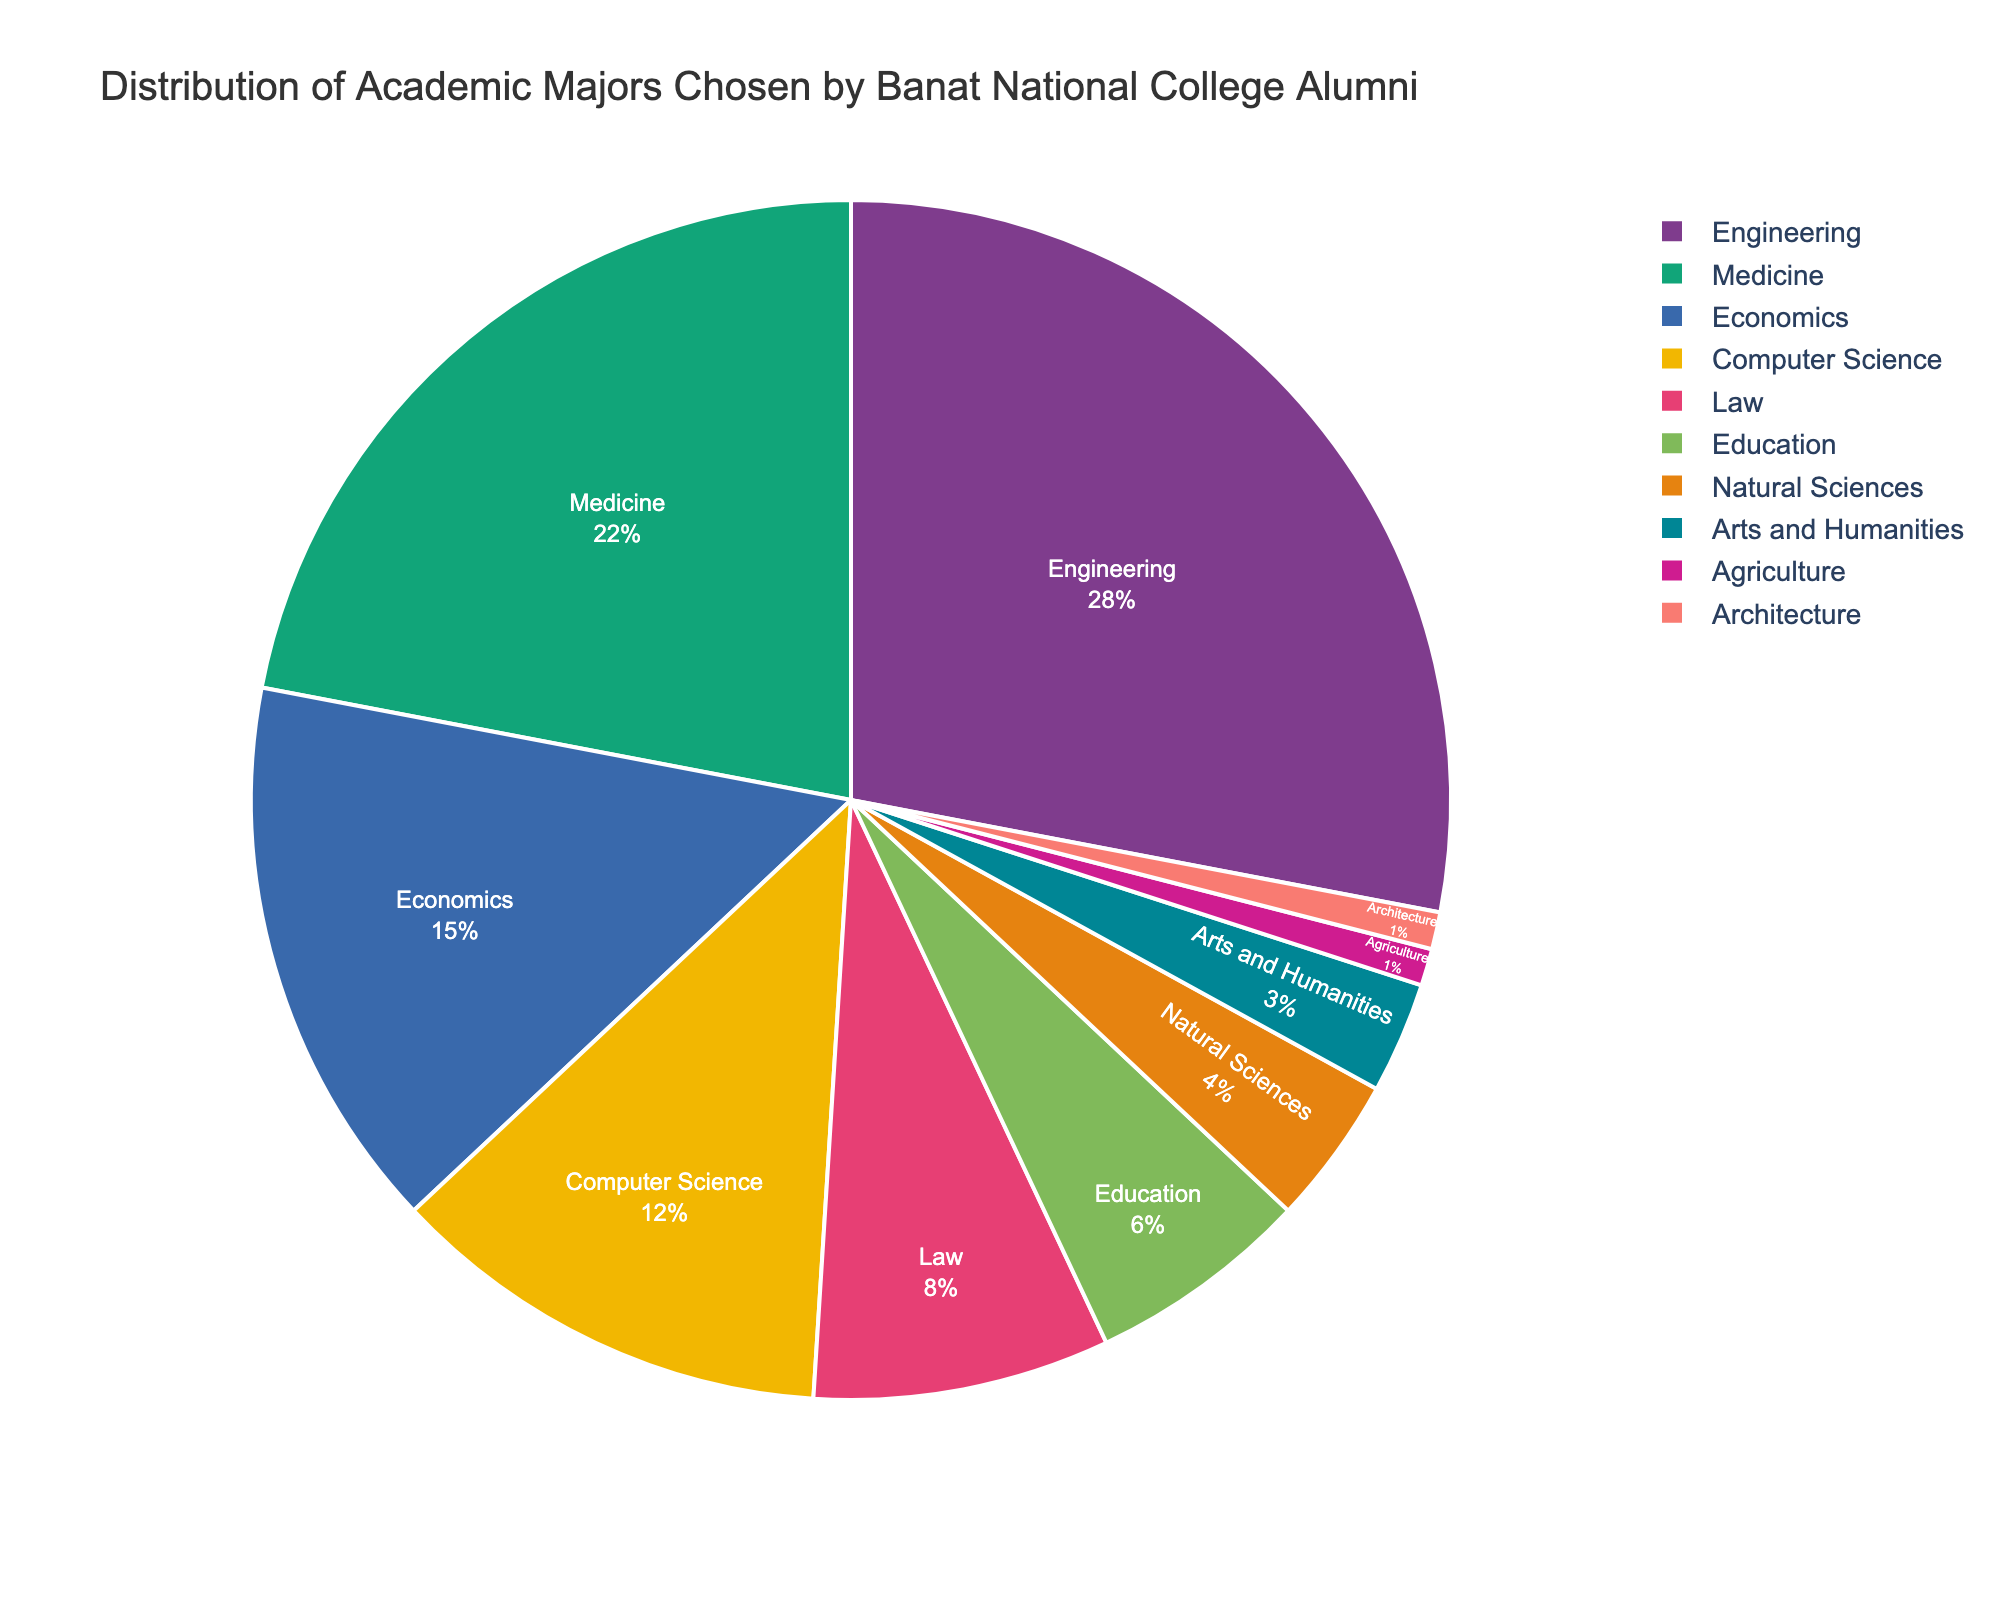Which major has the highest percentage of alumni? By visually inspecting the pie chart, we can see that Engineering appears to have the largest section. Confirm by noting it covers 28%.
Answer: Engineering What is the combined percentage of alumni in Medicine and Computer Science? From the pie chart, the Medicine slice is 22% and the Computer Science slice is 12%. Summing these two gives us 22 + 12 = 34%.
Answer: 34% How much more popular is Engineering compared to Law? Engineering has a percentage of 28%, while Law has 8%. Therefore, the difference is 28 - 8 = 20%.
Answer: 20% Which majors have a percentage below 5%? By examining the pie chart, we see that Natural Sciences (4%), Arts and Humanities (3%), Agriculture (1%), and Architecture (1%) each have a section smaller than 5%.
Answer: Natural Sciences, Arts and Humanities, Agriculture, Architecture How does the percentage of alumni in Economics compare to that in Education? Economics has a percentage of 15% and Education has 6%. Comparing the two, Economics has a greater percentage.
Answer: Economics is greater What is the total percentage of alumni in Natural Sciences, Arts and Humanities, Agriculture, and Architecture combined? Adding the percentages for these majors: 4% (Natural Sciences) + 3% (Arts and Humanities) + 1% (Agriculture) + 1% (Architecture) = 9%.
Answer: 9% What percentage of the alumni chose majors other than Engineering, Medicine, and Economics? The combined percentage of alumni in Engineering, Medicine, and Economics is 28% + 22% + 15% = 65%. Therefore, the percentage of alumni in other majors is 100% - 65% = 35%.
Answer: 35% Which major has the smallest percentage of alumni? From the pie chart, Agriculture and Architecture both have the smallest section, each representing 1%.
Answer: Agriculture, Architecture What is the difference in percentage between Computer Science and Arts and Humanities? Computer Science is 12% and Arts and Humanities is 3%. The difference is 12 - 3 = 9%.
Answer: 9% How does the percentage of alumni in Computer Science compare to the combined percentage of Education and Law? Computer Science has a percentage of 12%. The combined percentage of Education (6%) and Law (8%) is 6 + 8 = 14%. Comparing these, the combined percentage of Education and Law is greater.
Answer: Combined percentage of Education and Law is greater 